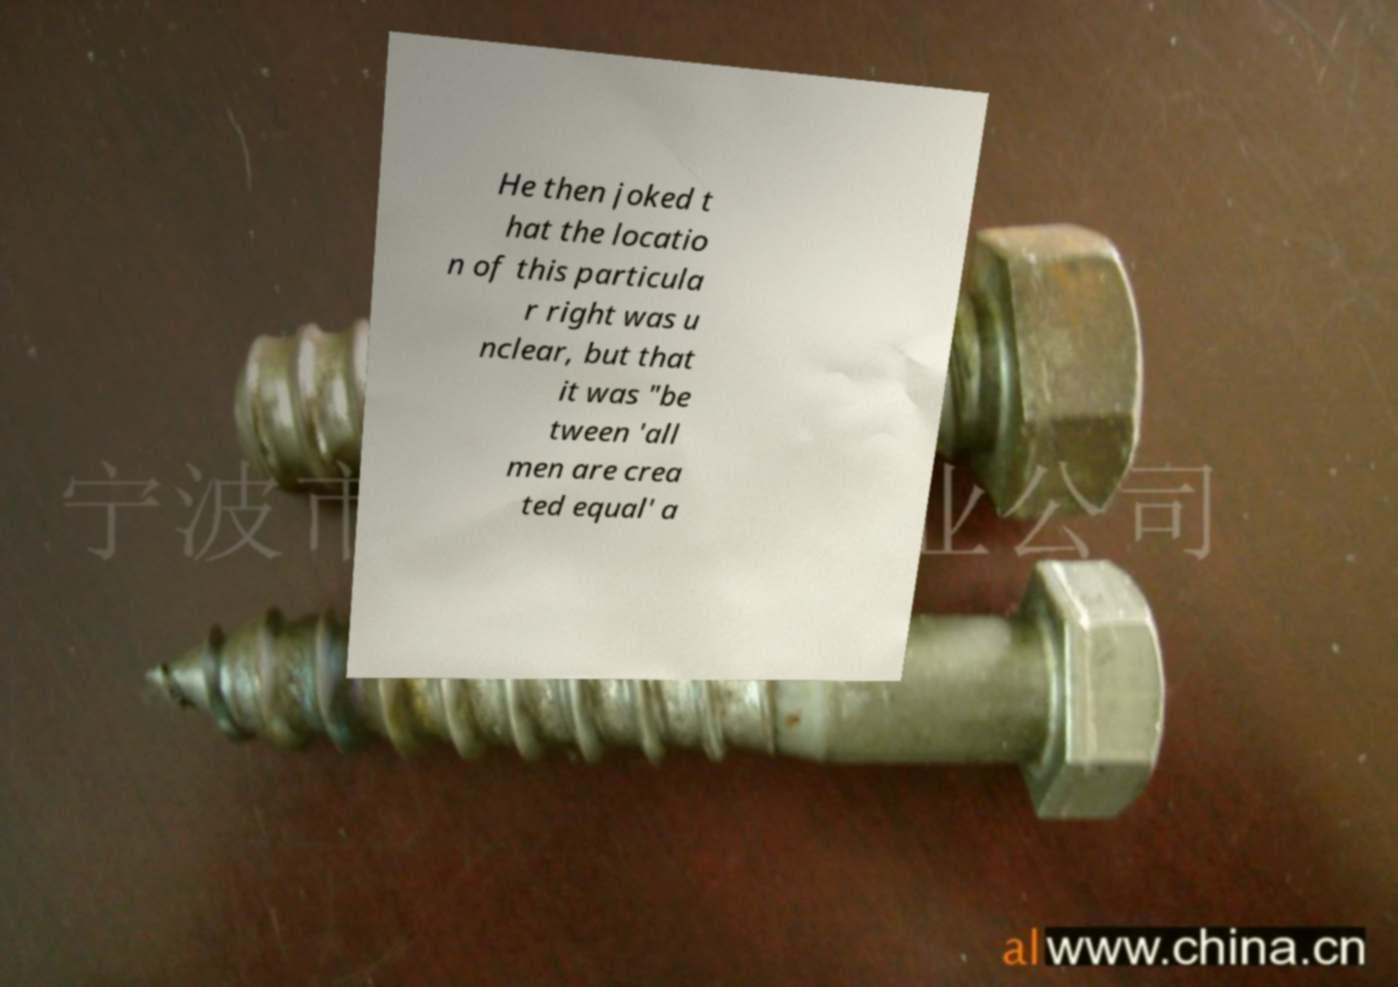There's text embedded in this image that I need extracted. Can you transcribe it verbatim? He then joked t hat the locatio n of this particula r right was u nclear, but that it was "be tween 'all men are crea ted equal' a 